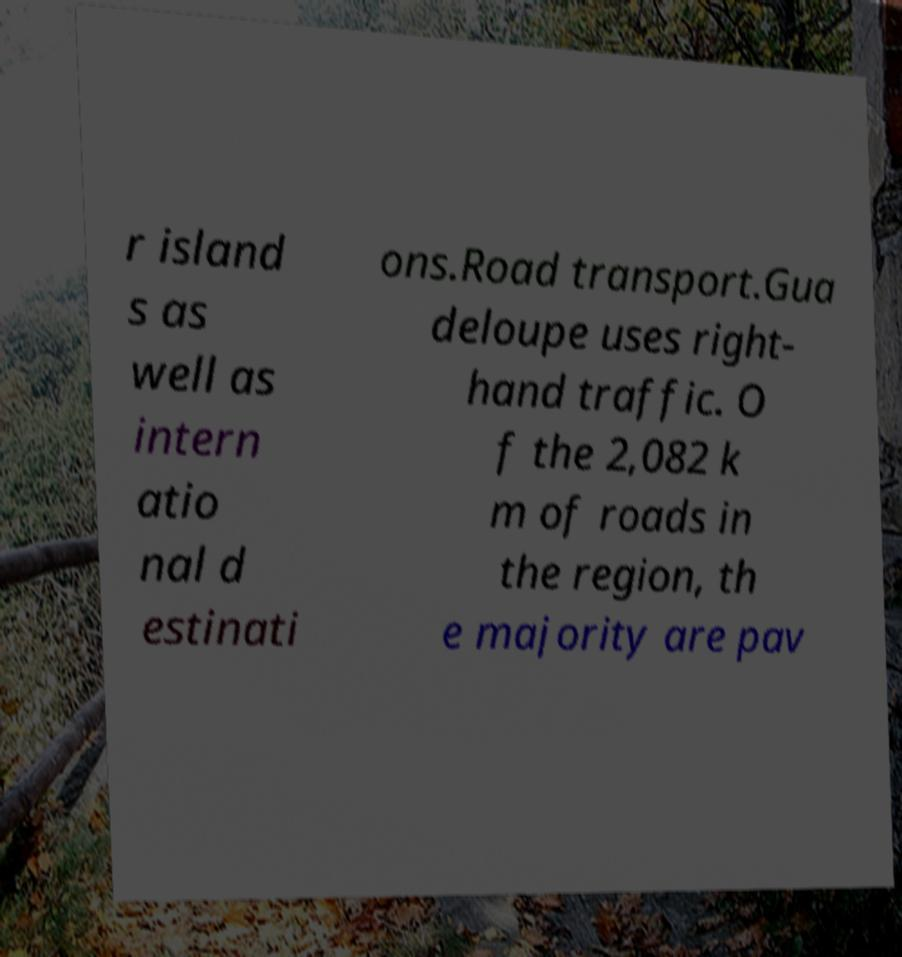For documentation purposes, I need the text within this image transcribed. Could you provide that? r island s as well as intern atio nal d estinati ons.Road transport.Gua deloupe uses right- hand traffic. O f the 2,082 k m of roads in the region, th e majority are pav 